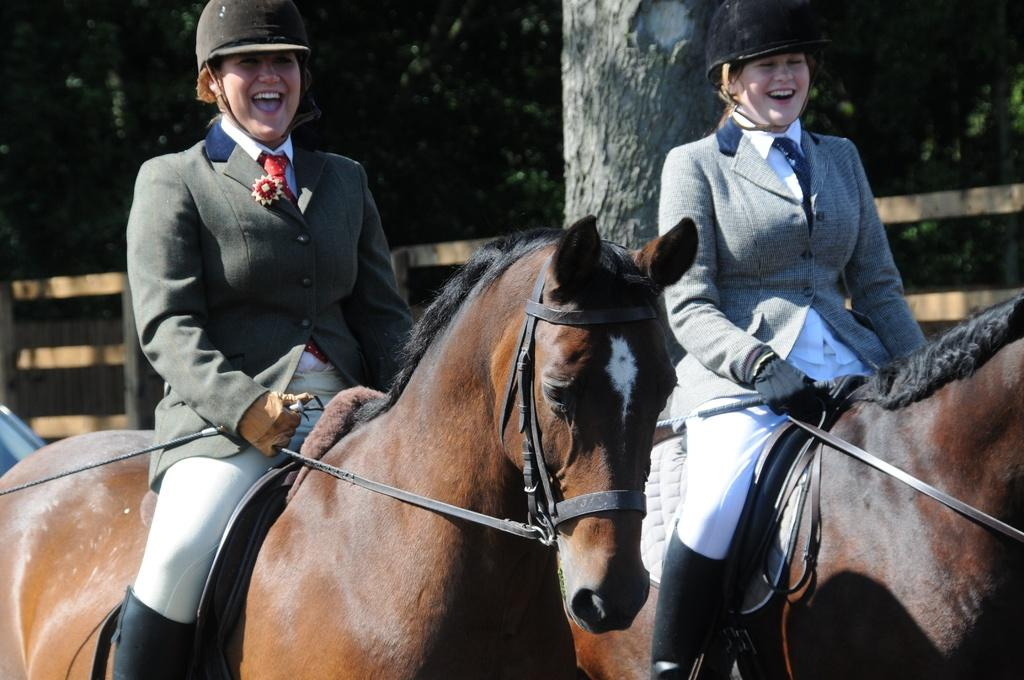How many people are in the image? There are two ladies in the image. What are the ladies doing in the image? The ladies are riding horses. What are the ladies holding while riding the horses? The ladies are holding sticks. What can be seen in the background of the image? There is a fence and trees in the background of the image. What type of tin can be seen being pushed by the ladies in the image? There is no tin present in the image, nor are the ladies pushing anything. 